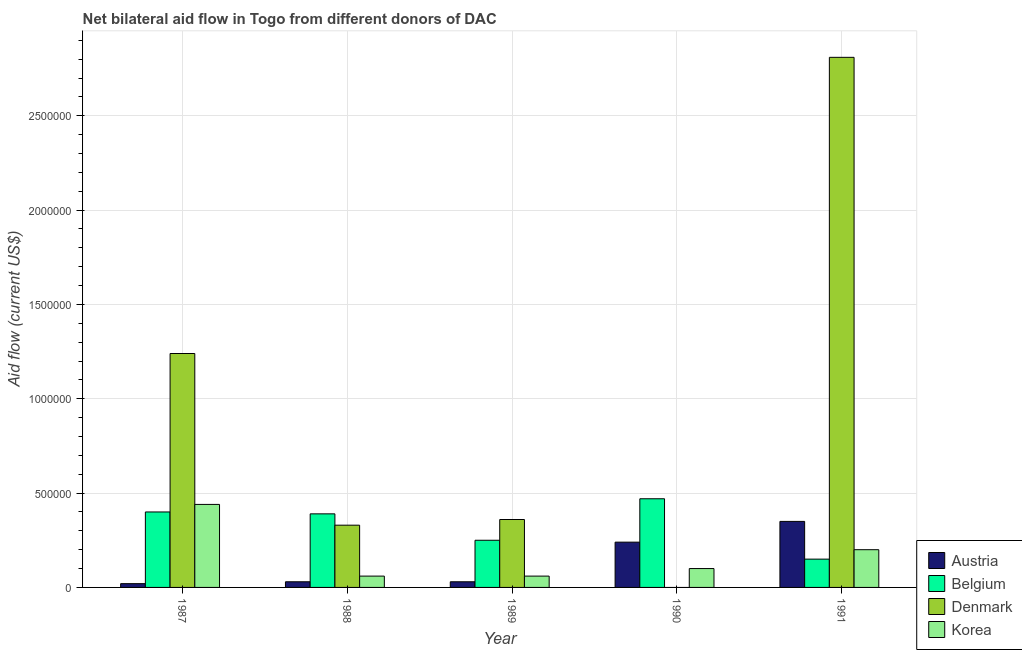How many groups of bars are there?
Provide a short and direct response. 5. How many bars are there on the 1st tick from the right?
Offer a terse response. 4. What is the amount of aid given by korea in 1990?
Make the answer very short. 1.00e+05. Across all years, what is the maximum amount of aid given by korea?
Offer a terse response. 4.40e+05. Across all years, what is the minimum amount of aid given by korea?
Your response must be concise. 6.00e+04. In which year was the amount of aid given by austria maximum?
Your answer should be very brief. 1991. What is the total amount of aid given by korea in the graph?
Your response must be concise. 8.60e+05. What is the difference between the amount of aid given by korea in 1989 and that in 1990?
Keep it short and to the point. -4.00e+04. What is the difference between the amount of aid given by denmark in 1989 and the amount of aid given by austria in 1990?
Keep it short and to the point. 3.60e+05. What is the average amount of aid given by belgium per year?
Offer a terse response. 3.32e+05. What is the ratio of the amount of aid given by denmark in 1989 to that in 1991?
Your answer should be very brief. 0.13. What is the difference between the highest and the second highest amount of aid given by denmark?
Your response must be concise. 1.57e+06. What is the difference between the highest and the lowest amount of aid given by korea?
Your answer should be compact. 3.80e+05. In how many years, is the amount of aid given by korea greater than the average amount of aid given by korea taken over all years?
Offer a terse response. 2. Is the sum of the amount of aid given by denmark in 1988 and 1989 greater than the maximum amount of aid given by austria across all years?
Give a very brief answer. No. Is it the case that in every year, the sum of the amount of aid given by korea and amount of aid given by austria is greater than the sum of amount of aid given by denmark and amount of aid given by belgium?
Your answer should be compact. No. How many bars are there?
Your answer should be compact. 19. Are all the bars in the graph horizontal?
Give a very brief answer. No. Does the graph contain any zero values?
Offer a very short reply. Yes. Does the graph contain grids?
Offer a very short reply. Yes. What is the title of the graph?
Make the answer very short. Net bilateral aid flow in Togo from different donors of DAC. Does "Iceland" appear as one of the legend labels in the graph?
Make the answer very short. No. What is the label or title of the Y-axis?
Your answer should be very brief. Aid flow (current US$). What is the Aid flow (current US$) in Belgium in 1987?
Your answer should be compact. 4.00e+05. What is the Aid flow (current US$) of Denmark in 1987?
Your response must be concise. 1.24e+06. What is the Aid flow (current US$) in Korea in 1987?
Offer a terse response. 4.40e+05. What is the Aid flow (current US$) of Belgium in 1988?
Ensure brevity in your answer.  3.90e+05. What is the Aid flow (current US$) of Denmark in 1988?
Offer a very short reply. 3.30e+05. What is the Aid flow (current US$) of Korea in 1988?
Your answer should be very brief. 6.00e+04. What is the Aid flow (current US$) of Belgium in 1989?
Offer a terse response. 2.50e+05. What is the Aid flow (current US$) of Denmark in 1989?
Keep it short and to the point. 3.60e+05. What is the Aid flow (current US$) in Austria in 1990?
Provide a succinct answer. 2.40e+05. What is the Aid flow (current US$) in Korea in 1990?
Make the answer very short. 1.00e+05. What is the Aid flow (current US$) of Belgium in 1991?
Keep it short and to the point. 1.50e+05. What is the Aid flow (current US$) in Denmark in 1991?
Your answer should be very brief. 2.81e+06. Across all years, what is the maximum Aid flow (current US$) in Denmark?
Your response must be concise. 2.81e+06. Across all years, what is the maximum Aid flow (current US$) in Korea?
Your answer should be very brief. 4.40e+05. Across all years, what is the minimum Aid flow (current US$) of Belgium?
Your response must be concise. 1.50e+05. What is the total Aid flow (current US$) in Austria in the graph?
Ensure brevity in your answer.  6.70e+05. What is the total Aid flow (current US$) of Belgium in the graph?
Provide a succinct answer. 1.66e+06. What is the total Aid flow (current US$) of Denmark in the graph?
Provide a succinct answer. 4.74e+06. What is the total Aid flow (current US$) of Korea in the graph?
Give a very brief answer. 8.60e+05. What is the difference between the Aid flow (current US$) of Austria in 1987 and that in 1988?
Make the answer very short. -10000. What is the difference between the Aid flow (current US$) of Belgium in 1987 and that in 1988?
Provide a short and direct response. 10000. What is the difference between the Aid flow (current US$) in Denmark in 1987 and that in 1988?
Your answer should be very brief. 9.10e+05. What is the difference between the Aid flow (current US$) in Belgium in 1987 and that in 1989?
Offer a very short reply. 1.50e+05. What is the difference between the Aid flow (current US$) in Denmark in 1987 and that in 1989?
Keep it short and to the point. 8.80e+05. What is the difference between the Aid flow (current US$) of Austria in 1987 and that in 1990?
Offer a terse response. -2.20e+05. What is the difference between the Aid flow (current US$) in Korea in 1987 and that in 1990?
Ensure brevity in your answer.  3.40e+05. What is the difference between the Aid flow (current US$) of Austria in 1987 and that in 1991?
Ensure brevity in your answer.  -3.30e+05. What is the difference between the Aid flow (current US$) of Denmark in 1987 and that in 1991?
Provide a succinct answer. -1.57e+06. What is the difference between the Aid flow (current US$) in Austria in 1988 and that in 1989?
Give a very brief answer. 0. What is the difference between the Aid flow (current US$) in Belgium in 1988 and that in 1989?
Offer a terse response. 1.40e+05. What is the difference between the Aid flow (current US$) of Korea in 1988 and that in 1989?
Your answer should be compact. 0. What is the difference between the Aid flow (current US$) in Austria in 1988 and that in 1990?
Make the answer very short. -2.10e+05. What is the difference between the Aid flow (current US$) of Korea in 1988 and that in 1990?
Provide a succinct answer. -4.00e+04. What is the difference between the Aid flow (current US$) of Austria in 1988 and that in 1991?
Make the answer very short. -3.20e+05. What is the difference between the Aid flow (current US$) in Denmark in 1988 and that in 1991?
Make the answer very short. -2.48e+06. What is the difference between the Aid flow (current US$) in Korea in 1988 and that in 1991?
Your response must be concise. -1.40e+05. What is the difference between the Aid flow (current US$) in Belgium in 1989 and that in 1990?
Give a very brief answer. -2.20e+05. What is the difference between the Aid flow (current US$) of Austria in 1989 and that in 1991?
Make the answer very short. -3.20e+05. What is the difference between the Aid flow (current US$) in Denmark in 1989 and that in 1991?
Ensure brevity in your answer.  -2.45e+06. What is the difference between the Aid flow (current US$) in Korea in 1989 and that in 1991?
Offer a terse response. -1.40e+05. What is the difference between the Aid flow (current US$) in Austria in 1990 and that in 1991?
Offer a very short reply. -1.10e+05. What is the difference between the Aid flow (current US$) of Austria in 1987 and the Aid flow (current US$) of Belgium in 1988?
Provide a short and direct response. -3.70e+05. What is the difference between the Aid flow (current US$) of Austria in 1987 and the Aid flow (current US$) of Denmark in 1988?
Provide a short and direct response. -3.10e+05. What is the difference between the Aid flow (current US$) in Belgium in 1987 and the Aid flow (current US$) in Denmark in 1988?
Provide a succinct answer. 7.00e+04. What is the difference between the Aid flow (current US$) in Belgium in 1987 and the Aid flow (current US$) in Korea in 1988?
Offer a terse response. 3.40e+05. What is the difference between the Aid flow (current US$) in Denmark in 1987 and the Aid flow (current US$) in Korea in 1988?
Your answer should be compact. 1.18e+06. What is the difference between the Aid flow (current US$) in Austria in 1987 and the Aid flow (current US$) in Belgium in 1989?
Give a very brief answer. -2.30e+05. What is the difference between the Aid flow (current US$) of Austria in 1987 and the Aid flow (current US$) of Korea in 1989?
Offer a terse response. -4.00e+04. What is the difference between the Aid flow (current US$) in Belgium in 1987 and the Aid flow (current US$) in Korea in 1989?
Make the answer very short. 3.40e+05. What is the difference between the Aid flow (current US$) in Denmark in 1987 and the Aid flow (current US$) in Korea in 1989?
Provide a short and direct response. 1.18e+06. What is the difference between the Aid flow (current US$) of Austria in 1987 and the Aid flow (current US$) of Belgium in 1990?
Offer a very short reply. -4.50e+05. What is the difference between the Aid flow (current US$) in Denmark in 1987 and the Aid flow (current US$) in Korea in 1990?
Offer a terse response. 1.14e+06. What is the difference between the Aid flow (current US$) of Austria in 1987 and the Aid flow (current US$) of Denmark in 1991?
Your response must be concise. -2.79e+06. What is the difference between the Aid flow (current US$) in Austria in 1987 and the Aid flow (current US$) in Korea in 1991?
Ensure brevity in your answer.  -1.80e+05. What is the difference between the Aid flow (current US$) of Belgium in 1987 and the Aid flow (current US$) of Denmark in 1991?
Provide a short and direct response. -2.41e+06. What is the difference between the Aid flow (current US$) of Belgium in 1987 and the Aid flow (current US$) of Korea in 1991?
Offer a very short reply. 2.00e+05. What is the difference between the Aid flow (current US$) of Denmark in 1987 and the Aid flow (current US$) of Korea in 1991?
Your answer should be compact. 1.04e+06. What is the difference between the Aid flow (current US$) of Austria in 1988 and the Aid flow (current US$) of Belgium in 1989?
Your answer should be compact. -2.20e+05. What is the difference between the Aid flow (current US$) in Austria in 1988 and the Aid flow (current US$) in Denmark in 1989?
Ensure brevity in your answer.  -3.30e+05. What is the difference between the Aid flow (current US$) of Austria in 1988 and the Aid flow (current US$) of Korea in 1989?
Keep it short and to the point. -3.00e+04. What is the difference between the Aid flow (current US$) in Austria in 1988 and the Aid flow (current US$) in Belgium in 1990?
Give a very brief answer. -4.40e+05. What is the difference between the Aid flow (current US$) of Austria in 1988 and the Aid flow (current US$) of Korea in 1990?
Your answer should be very brief. -7.00e+04. What is the difference between the Aid flow (current US$) of Belgium in 1988 and the Aid flow (current US$) of Korea in 1990?
Make the answer very short. 2.90e+05. What is the difference between the Aid flow (current US$) of Denmark in 1988 and the Aid flow (current US$) of Korea in 1990?
Your answer should be compact. 2.30e+05. What is the difference between the Aid flow (current US$) of Austria in 1988 and the Aid flow (current US$) of Belgium in 1991?
Make the answer very short. -1.20e+05. What is the difference between the Aid flow (current US$) of Austria in 1988 and the Aid flow (current US$) of Denmark in 1991?
Provide a short and direct response. -2.78e+06. What is the difference between the Aid flow (current US$) in Belgium in 1988 and the Aid flow (current US$) in Denmark in 1991?
Offer a very short reply. -2.42e+06. What is the difference between the Aid flow (current US$) of Belgium in 1988 and the Aid flow (current US$) of Korea in 1991?
Your response must be concise. 1.90e+05. What is the difference between the Aid flow (current US$) of Austria in 1989 and the Aid flow (current US$) of Belgium in 1990?
Offer a very short reply. -4.40e+05. What is the difference between the Aid flow (current US$) in Belgium in 1989 and the Aid flow (current US$) in Korea in 1990?
Give a very brief answer. 1.50e+05. What is the difference between the Aid flow (current US$) of Austria in 1989 and the Aid flow (current US$) of Denmark in 1991?
Make the answer very short. -2.78e+06. What is the difference between the Aid flow (current US$) of Belgium in 1989 and the Aid flow (current US$) of Denmark in 1991?
Keep it short and to the point. -2.56e+06. What is the difference between the Aid flow (current US$) in Belgium in 1989 and the Aid flow (current US$) in Korea in 1991?
Your answer should be very brief. 5.00e+04. What is the difference between the Aid flow (current US$) in Denmark in 1989 and the Aid flow (current US$) in Korea in 1991?
Make the answer very short. 1.60e+05. What is the difference between the Aid flow (current US$) of Austria in 1990 and the Aid flow (current US$) of Denmark in 1991?
Provide a short and direct response. -2.57e+06. What is the difference between the Aid flow (current US$) in Austria in 1990 and the Aid flow (current US$) in Korea in 1991?
Offer a very short reply. 4.00e+04. What is the difference between the Aid flow (current US$) of Belgium in 1990 and the Aid flow (current US$) of Denmark in 1991?
Keep it short and to the point. -2.34e+06. What is the difference between the Aid flow (current US$) of Belgium in 1990 and the Aid flow (current US$) of Korea in 1991?
Make the answer very short. 2.70e+05. What is the average Aid flow (current US$) of Austria per year?
Provide a succinct answer. 1.34e+05. What is the average Aid flow (current US$) of Belgium per year?
Give a very brief answer. 3.32e+05. What is the average Aid flow (current US$) of Denmark per year?
Offer a very short reply. 9.48e+05. What is the average Aid flow (current US$) in Korea per year?
Your answer should be very brief. 1.72e+05. In the year 1987, what is the difference between the Aid flow (current US$) of Austria and Aid flow (current US$) of Belgium?
Keep it short and to the point. -3.80e+05. In the year 1987, what is the difference between the Aid flow (current US$) of Austria and Aid flow (current US$) of Denmark?
Your response must be concise. -1.22e+06. In the year 1987, what is the difference between the Aid flow (current US$) of Austria and Aid flow (current US$) of Korea?
Your answer should be compact. -4.20e+05. In the year 1987, what is the difference between the Aid flow (current US$) of Belgium and Aid flow (current US$) of Denmark?
Your answer should be compact. -8.40e+05. In the year 1987, what is the difference between the Aid flow (current US$) of Denmark and Aid flow (current US$) of Korea?
Keep it short and to the point. 8.00e+05. In the year 1988, what is the difference between the Aid flow (current US$) of Austria and Aid flow (current US$) of Belgium?
Offer a terse response. -3.60e+05. In the year 1988, what is the difference between the Aid flow (current US$) in Austria and Aid flow (current US$) in Denmark?
Your answer should be compact. -3.00e+05. In the year 1988, what is the difference between the Aid flow (current US$) of Belgium and Aid flow (current US$) of Denmark?
Your answer should be compact. 6.00e+04. In the year 1989, what is the difference between the Aid flow (current US$) of Austria and Aid flow (current US$) of Belgium?
Ensure brevity in your answer.  -2.20e+05. In the year 1989, what is the difference between the Aid flow (current US$) in Austria and Aid flow (current US$) in Denmark?
Offer a very short reply. -3.30e+05. In the year 1989, what is the difference between the Aid flow (current US$) of Belgium and Aid flow (current US$) of Korea?
Offer a very short reply. 1.90e+05. In the year 1990, what is the difference between the Aid flow (current US$) in Austria and Aid flow (current US$) in Korea?
Offer a very short reply. 1.40e+05. In the year 1990, what is the difference between the Aid flow (current US$) of Belgium and Aid flow (current US$) of Korea?
Give a very brief answer. 3.70e+05. In the year 1991, what is the difference between the Aid flow (current US$) of Austria and Aid flow (current US$) of Belgium?
Offer a very short reply. 2.00e+05. In the year 1991, what is the difference between the Aid flow (current US$) in Austria and Aid flow (current US$) in Denmark?
Make the answer very short. -2.46e+06. In the year 1991, what is the difference between the Aid flow (current US$) of Belgium and Aid flow (current US$) of Denmark?
Ensure brevity in your answer.  -2.66e+06. In the year 1991, what is the difference between the Aid flow (current US$) of Belgium and Aid flow (current US$) of Korea?
Make the answer very short. -5.00e+04. In the year 1991, what is the difference between the Aid flow (current US$) of Denmark and Aid flow (current US$) of Korea?
Your response must be concise. 2.61e+06. What is the ratio of the Aid flow (current US$) in Austria in 1987 to that in 1988?
Offer a very short reply. 0.67. What is the ratio of the Aid flow (current US$) in Belgium in 1987 to that in 1988?
Your response must be concise. 1.03. What is the ratio of the Aid flow (current US$) of Denmark in 1987 to that in 1988?
Your answer should be very brief. 3.76. What is the ratio of the Aid flow (current US$) of Korea in 1987 to that in 1988?
Keep it short and to the point. 7.33. What is the ratio of the Aid flow (current US$) of Austria in 1987 to that in 1989?
Your answer should be compact. 0.67. What is the ratio of the Aid flow (current US$) of Denmark in 1987 to that in 1989?
Give a very brief answer. 3.44. What is the ratio of the Aid flow (current US$) in Korea in 1987 to that in 1989?
Ensure brevity in your answer.  7.33. What is the ratio of the Aid flow (current US$) in Austria in 1987 to that in 1990?
Ensure brevity in your answer.  0.08. What is the ratio of the Aid flow (current US$) of Belgium in 1987 to that in 1990?
Provide a succinct answer. 0.85. What is the ratio of the Aid flow (current US$) in Austria in 1987 to that in 1991?
Your answer should be compact. 0.06. What is the ratio of the Aid flow (current US$) of Belgium in 1987 to that in 1991?
Provide a short and direct response. 2.67. What is the ratio of the Aid flow (current US$) of Denmark in 1987 to that in 1991?
Make the answer very short. 0.44. What is the ratio of the Aid flow (current US$) of Korea in 1987 to that in 1991?
Provide a short and direct response. 2.2. What is the ratio of the Aid flow (current US$) in Austria in 1988 to that in 1989?
Provide a short and direct response. 1. What is the ratio of the Aid flow (current US$) of Belgium in 1988 to that in 1989?
Ensure brevity in your answer.  1.56. What is the ratio of the Aid flow (current US$) in Denmark in 1988 to that in 1989?
Offer a terse response. 0.92. What is the ratio of the Aid flow (current US$) of Austria in 1988 to that in 1990?
Provide a short and direct response. 0.12. What is the ratio of the Aid flow (current US$) in Belgium in 1988 to that in 1990?
Your response must be concise. 0.83. What is the ratio of the Aid flow (current US$) in Korea in 1988 to that in 1990?
Your answer should be compact. 0.6. What is the ratio of the Aid flow (current US$) in Austria in 1988 to that in 1991?
Provide a short and direct response. 0.09. What is the ratio of the Aid flow (current US$) in Belgium in 1988 to that in 1991?
Offer a very short reply. 2.6. What is the ratio of the Aid flow (current US$) in Denmark in 1988 to that in 1991?
Provide a short and direct response. 0.12. What is the ratio of the Aid flow (current US$) in Korea in 1988 to that in 1991?
Give a very brief answer. 0.3. What is the ratio of the Aid flow (current US$) of Austria in 1989 to that in 1990?
Give a very brief answer. 0.12. What is the ratio of the Aid flow (current US$) in Belgium in 1989 to that in 1990?
Make the answer very short. 0.53. What is the ratio of the Aid flow (current US$) in Austria in 1989 to that in 1991?
Make the answer very short. 0.09. What is the ratio of the Aid flow (current US$) in Belgium in 1989 to that in 1991?
Ensure brevity in your answer.  1.67. What is the ratio of the Aid flow (current US$) of Denmark in 1989 to that in 1991?
Provide a short and direct response. 0.13. What is the ratio of the Aid flow (current US$) of Korea in 1989 to that in 1991?
Ensure brevity in your answer.  0.3. What is the ratio of the Aid flow (current US$) in Austria in 1990 to that in 1991?
Provide a short and direct response. 0.69. What is the ratio of the Aid flow (current US$) of Belgium in 1990 to that in 1991?
Your answer should be very brief. 3.13. What is the difference between the highest and the second highest Aid flow (current US$) of Denmark?
Your answer should be compact. 1.57e+06. What is the difference between the highest and the second highest Aid flow (current US$) of Korea?
Your response must be concise. 2.40e+05. What is the difference between the highest and the lowest Aid flow (current US$) in Denmark?
Provide a short and direct response. 2.81e+06. What is the difference between the highest and the lowest Aid flow (current US$) in Korea?
Your answer should be compact. 3.80e+05. 